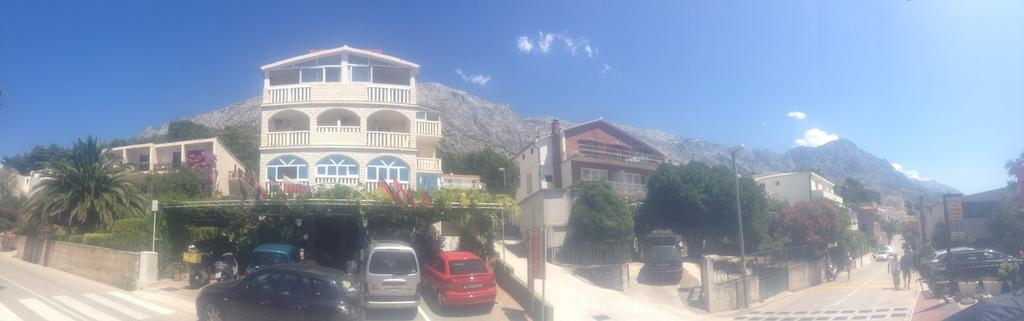What type of structures can be seen in the image? There are buildings in the image. What mode of transportation is visible in the image? Cars are visible in the image. What vertical structures are present in the image? Electric poles are visible in the image. Who or what can be seen in the image? There are people in the image. What type of vegetation is present in the image? Trees, plants, and flowers are present in the image. What can be seen in the background of the image? Hills and the sky are visible in the background of the image. What type of canvas is being used by the dad in the image? There is no dad or canvas present in the image. What is the birth rate of the flowers in the image? The image does not provide information about the birth rate of the flowers. 